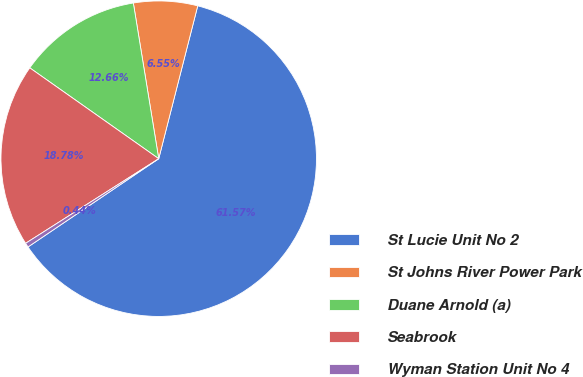Convert chart. <chart><loc_0><loc_0><loc_500><loc_500><pie_chart><fcel>St Lucie Unit No 2<fcel>St Johns River Power Park<fcel>Duane Arnold (a)<fcel>Seabrook<fcel>Wyman Station Unit No 4<nl><fcel>61.57%<fcel>6.55%<fcel>12.66%<fcel>18.78%<fcel>0.44%<nl></chart> 